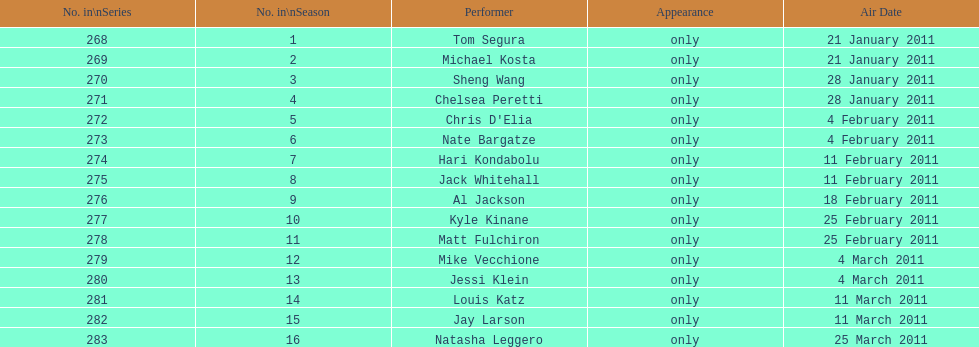In how many episodes did just one performer appear? 16. 